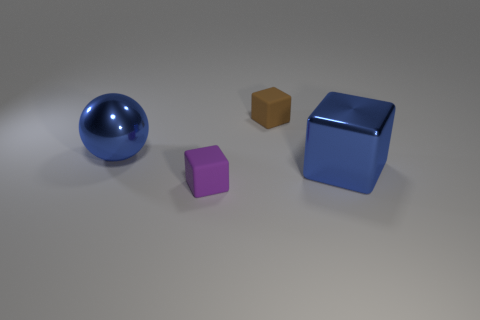Add 4 large cyan rubber blocks. How many objects exist? 8 Subtract all blocks. How many objects are left? 1 Subtract 0 purple spheres. How many objects are left? 4 Subtract all purple rubber objects. Subtract all blue metal things. How many objects are left? 1 Add 4 purple cubes. How many purple cubes are left? 5 Add 2 small gray rubber balls. How many small gray rubber balls exist? 2 